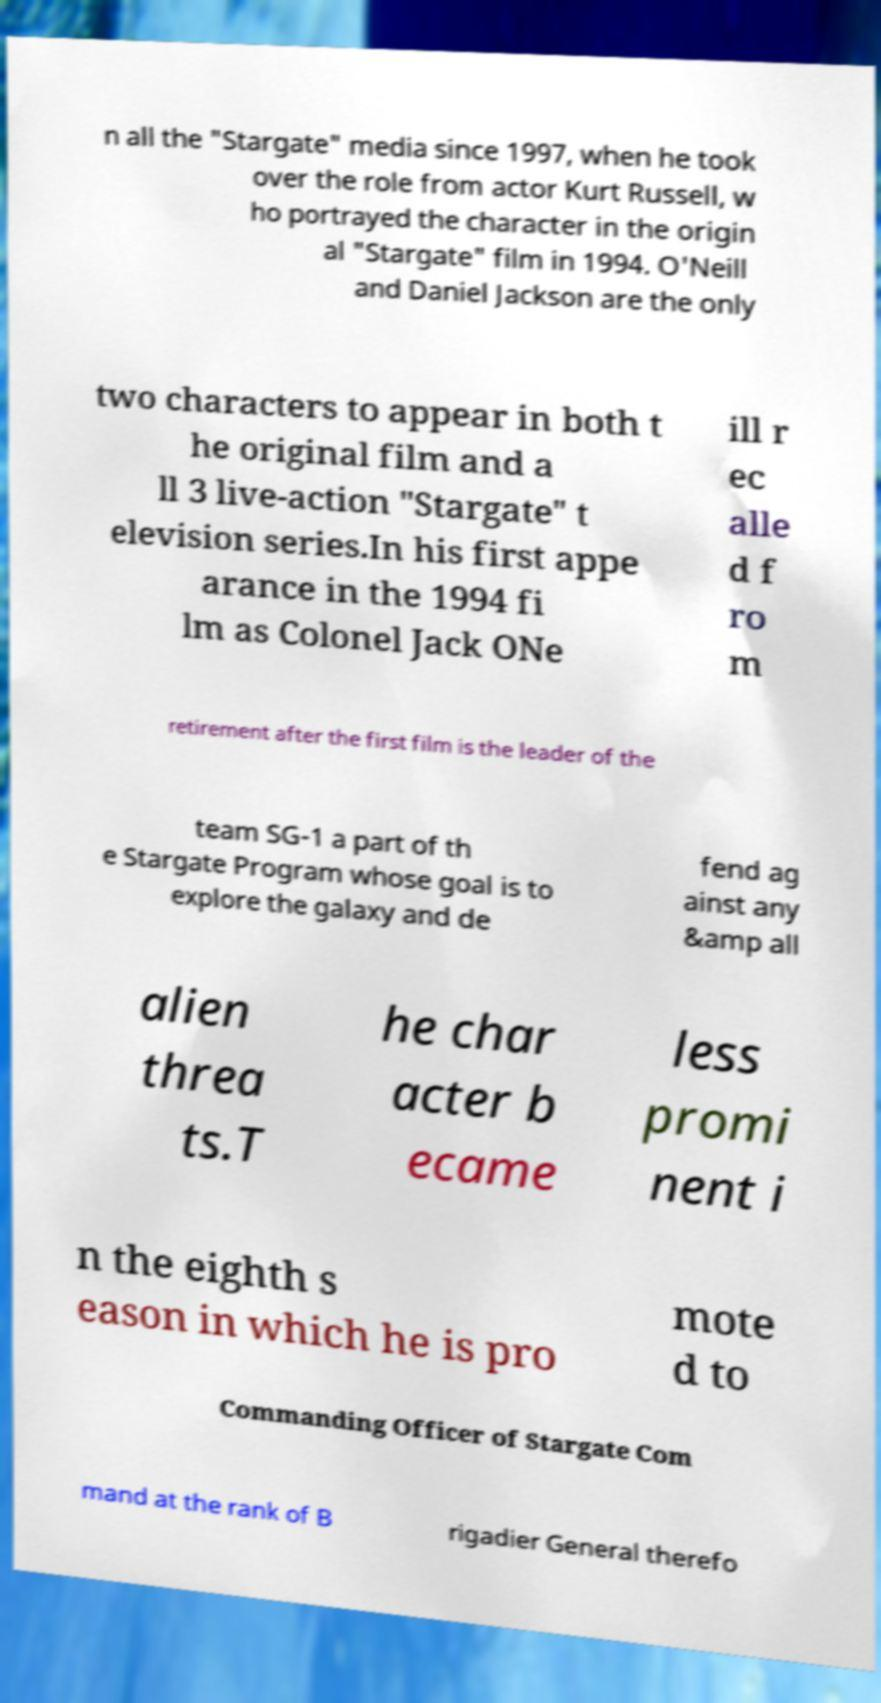There's text embedded in this image that I need extracted. Can you transcribe it verbatim? n all the "Stargate" media since 1997, when he took over the role from actor Kurt Russell, w ho portrayed the character in the origin al "Stargate" film in 1994. O'Neill and Daniel Jackson are the only two characters to appear in both t he original film and a ll 3 live-action "Stargate" t elevision series.In his first appe arance in the 1994 fi lm as Colonel Jack ONe ill r ec alle d f ro m retirement after the first film is the leader of the team SG-1 a part of th e Stargate Program whose goal is to explore the galaxy and de fend ag ainst any &amp all alien threa ts.T he char acter b ecame less promi nent i n the eighth s eason in which he is pro mote d to Commanding Officer of Stargate Com mand at the rank of B rigadier General therefo 